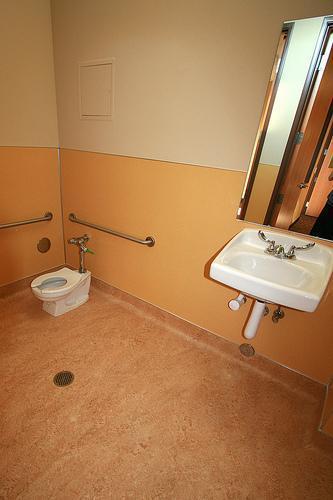How many toilets are in the picture?
Give a very brief answer. 1. 